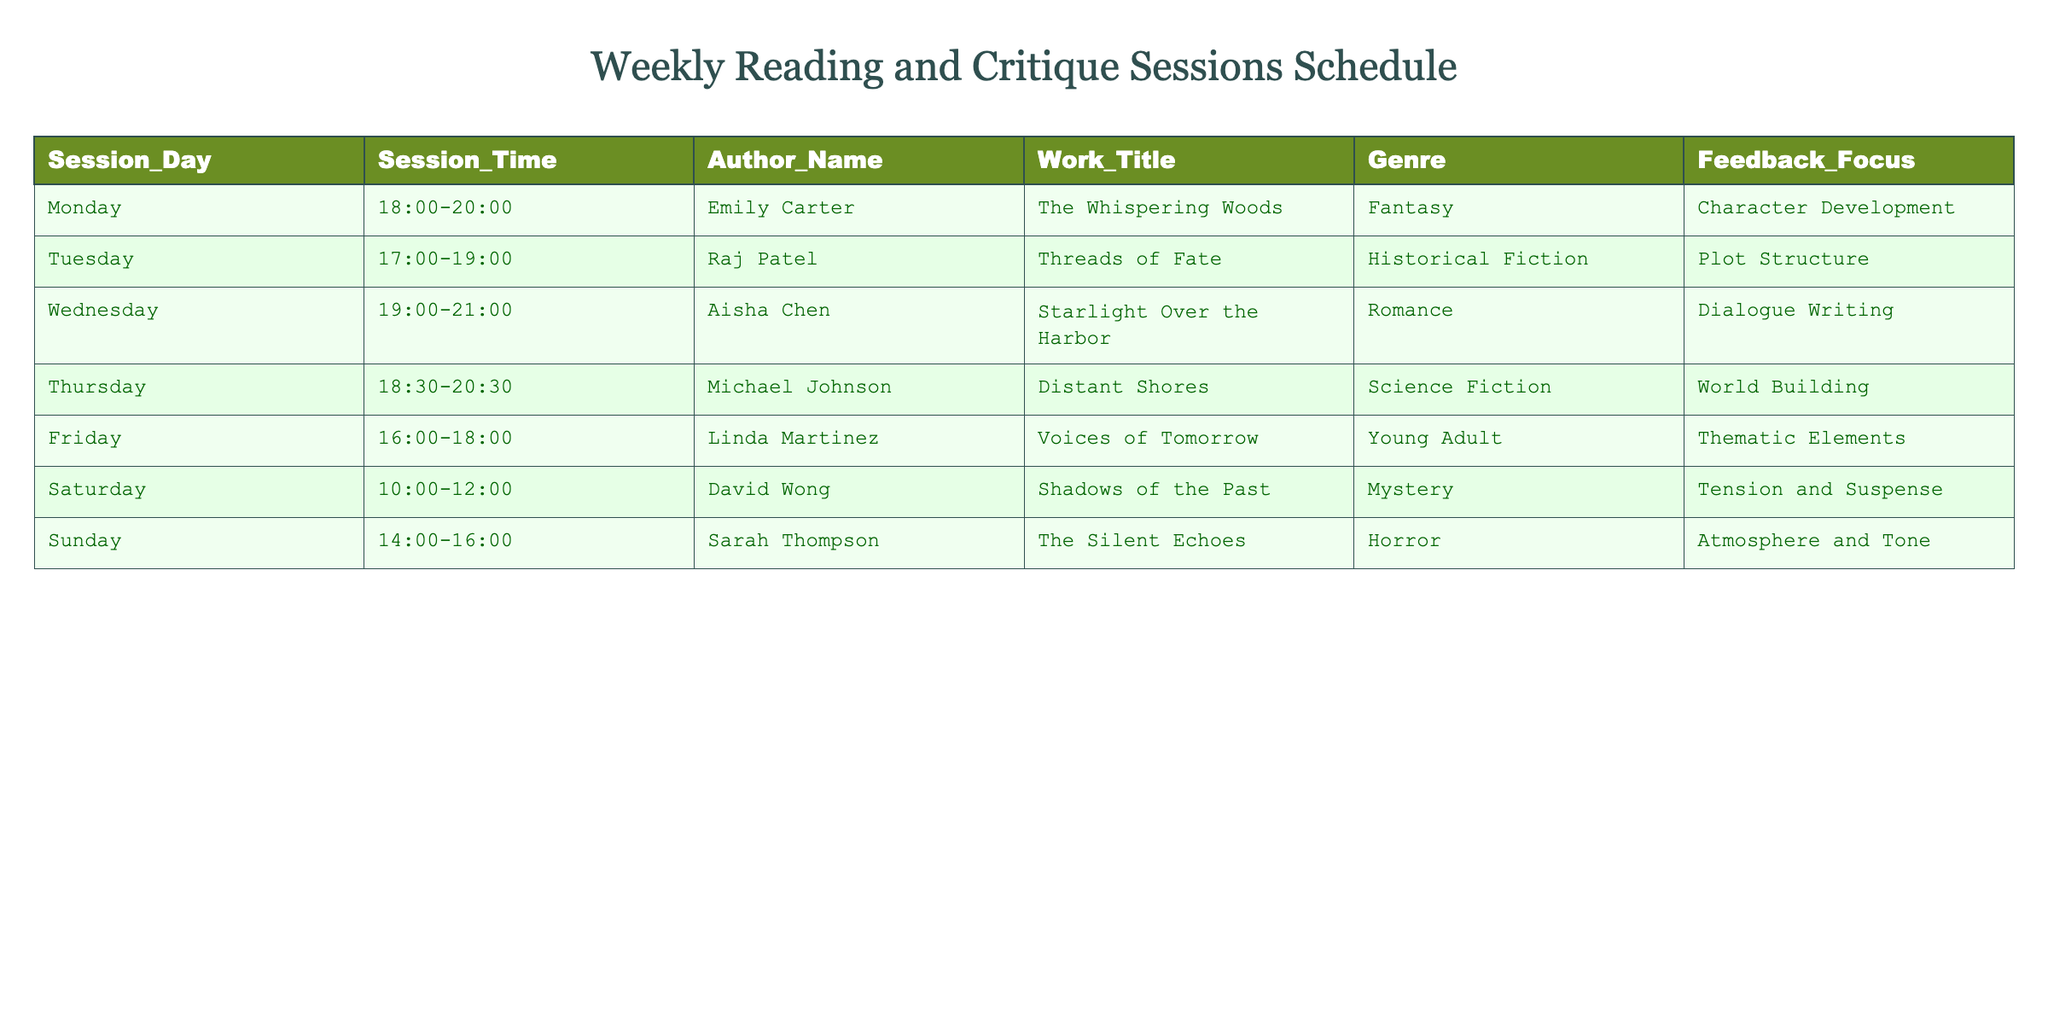What is the genre of Linda Martinez's work? Linda Martinez's work, titled "Voices of Tomorrow," is listed in the genre column of the table. By locating her name, one can directly read the corresponding genre across the same row.
Answer: Young Adult Which author is scheduled for the critique session on Wednesday? The table lists the scheduled sessions for each day along with the corresponding authors. Looking under Wednesday in the Session_Day column, Aisha Chen is mentioned for that day.
Answer: Aisha Chen How many authors are focusing on character development in their work? To find the number of authors focusing on character development, we can filter the feedback focus column for "Character Development." In the table, only Emily Carter's session is associated with this feedback focus.
Answer: 1 What is the average session time across all critique sessions? The session times can be approached by converting them into a 24-hour time format to calculate their duration. After determining the start and end times for all sessions, we can follow these assumptions: 2 hours for the 6 sessions from Monday to Sunday, and calculate the total time as (6 hours * 8 sessions = 48 hours). Dividing by 7 days gives an average of approximately 6.86 hours.
Answer: Approximately 6.86 hours Is there a session on Saturday? The table outlines the schedule for critique sessions throughout the week; searching the Session_Day column confirms that Saturday indeed has a session scheduled thus supporting a "Yes" response.
Answer: Yes Which genres are represented on Thursday and Friday? To answer this, we need to identify the sessions scheduled on Thursday and Friday by checking the corresponding entries in the table for those days. Thursday has Michael Johnson with Science Fiction and Friday has Linda Martinez with Young Adult.
Answer: Science Fiction and Young Adult How many hours in total are allocated for sessions focused on romance and horror? First, find the hour allocations for the romance and horror sessions, specifically Aisha Chen on Wednesday (2 hours) and Sarah Thompson on Sunday (2 hours). Summing these gives 2 hours + 2 hours = 4 hours total.
Answer: 4 hours 